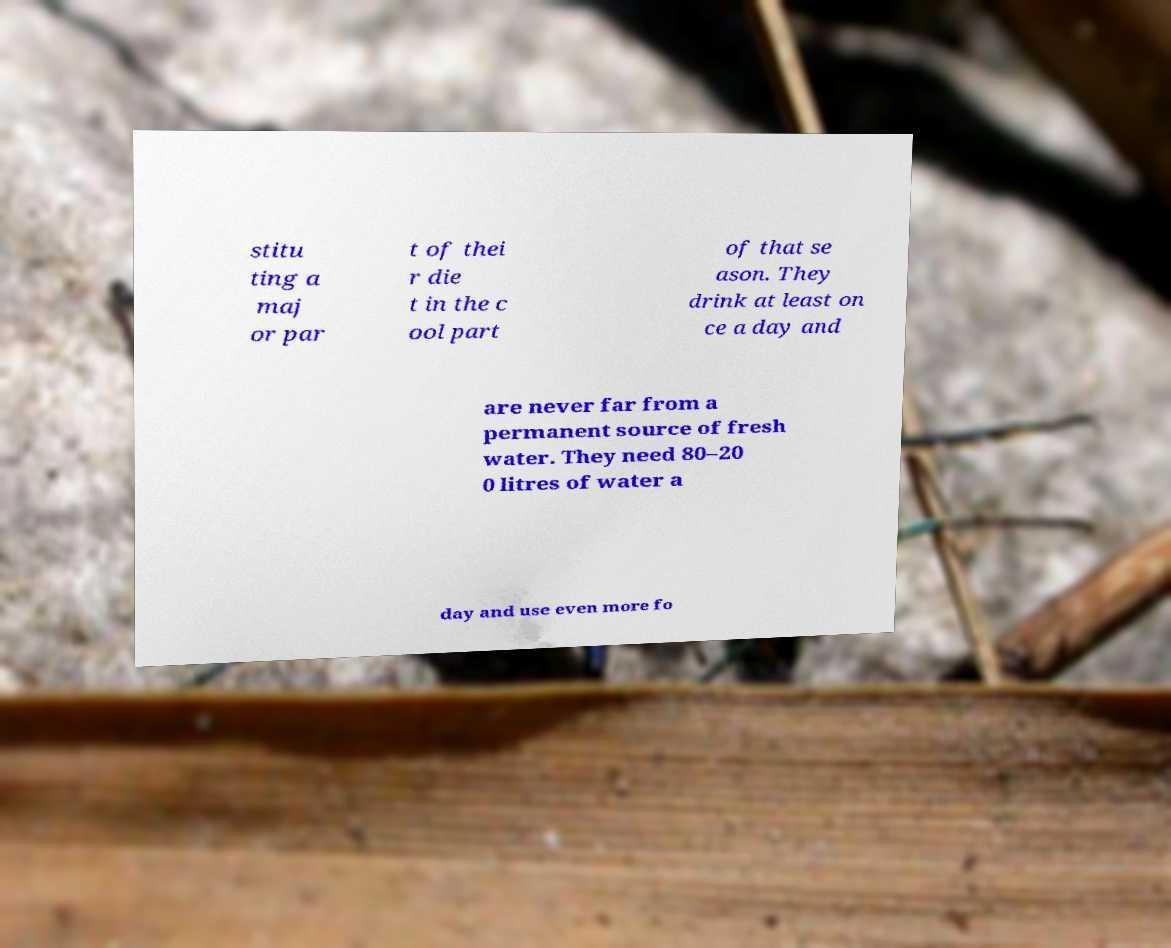I need the written content from this picture converted into text. Can you do that? stitu ting a maj or par t of thei r die t in the c ool part of that se ason. They drink at least on ce a day and are never far from a permanent source of fresh water. They need 80–20 0 litres of water a day and use even more fo 